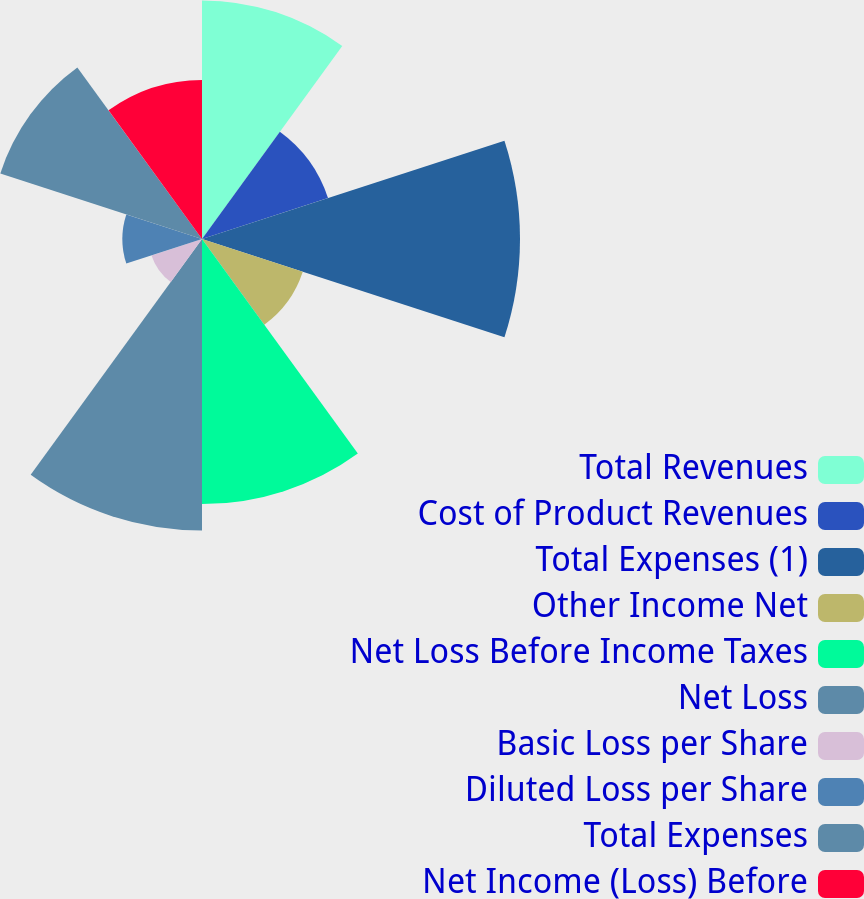Convert chart. <chart><loc_0><loc_0><loc_500><loc_500><pie_chart><fcel>Total Revenues<fcel>Cost of Product Revenues<fcel>Total Expenses (1)<fcel>Other Income Net<fcel>Net Loss Before Income Taxes<fcel>Net Loss<fcel>Basic Loss per Share<fcel>Diluted Loss per Share<fcel>Total Expenses<fcel>Net Income (Loss) Before<nl><fcel>12.86%<fcel>7.14%<fcel>17.14%<fcel>5.71%<fcel>14.29%<fcel>15.71%<fcel>2.86%<fcel>4.29%<fcel>11.43%<fcel>8.57%<nl></chart> 